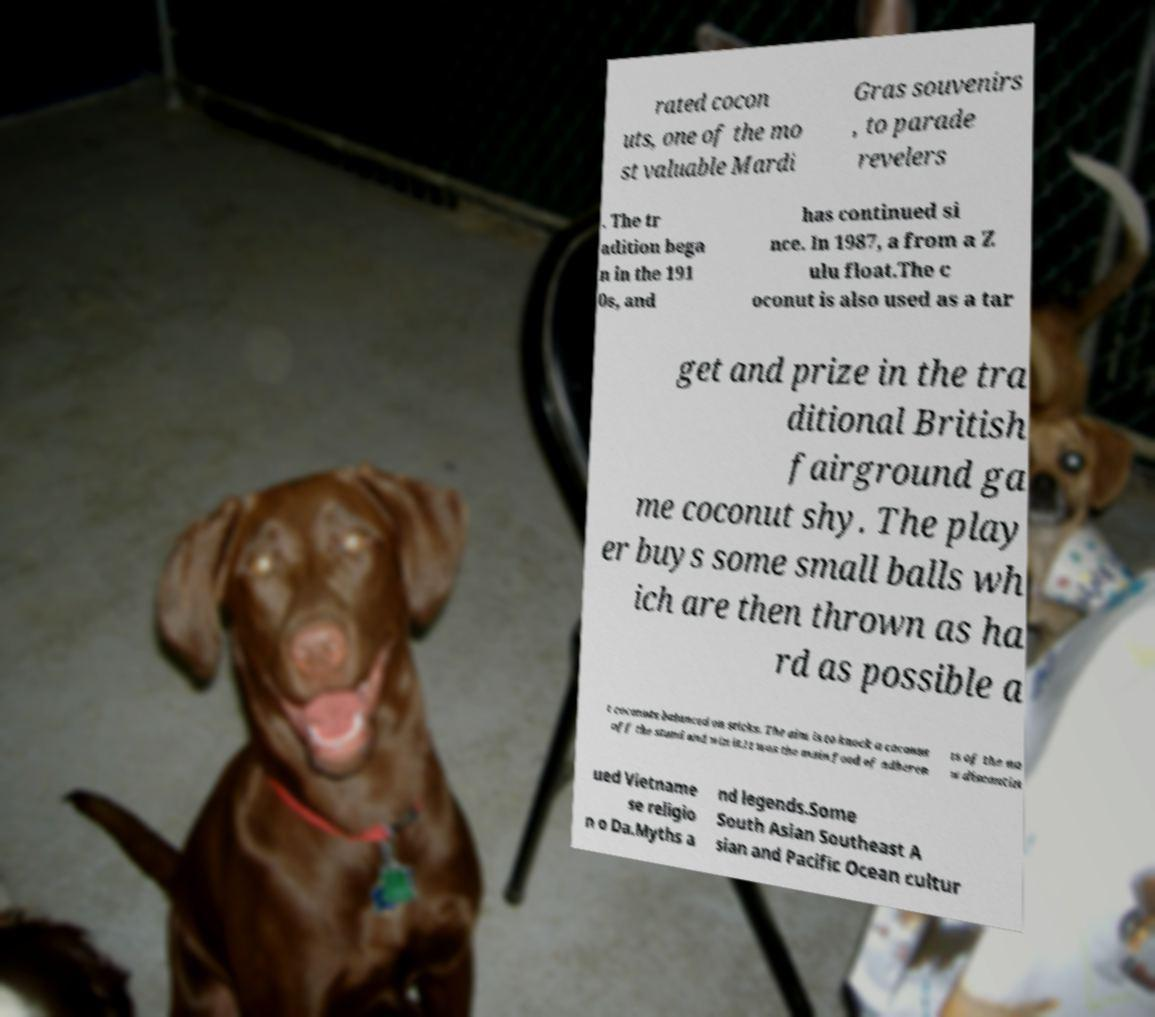There's text embedded in this image that I need extracted. Can you transcribe it verbatim? rated cocon uts, one of the mo st valuable Mardi Gras souvenirs , to parade revelers . The tr adition bega n in the 191 0s, and has continued si nce. In 1987, a from a Z ulu float.The c oconut is also used as a tar get and prize in the tra ditional British fairground ga me coconut shy. The play er buys some small balls wh ich are then thrown as ha rd as possible a t coconuts balanced on sticks. The aim is to knock a coconut off the stand and win it.It was the main food of adheren ts of the no w discontin ued Vietname se religio n o Da.Myths a nd legends.Some South Asian Southeast A sian and Pacific Ocean cultur 